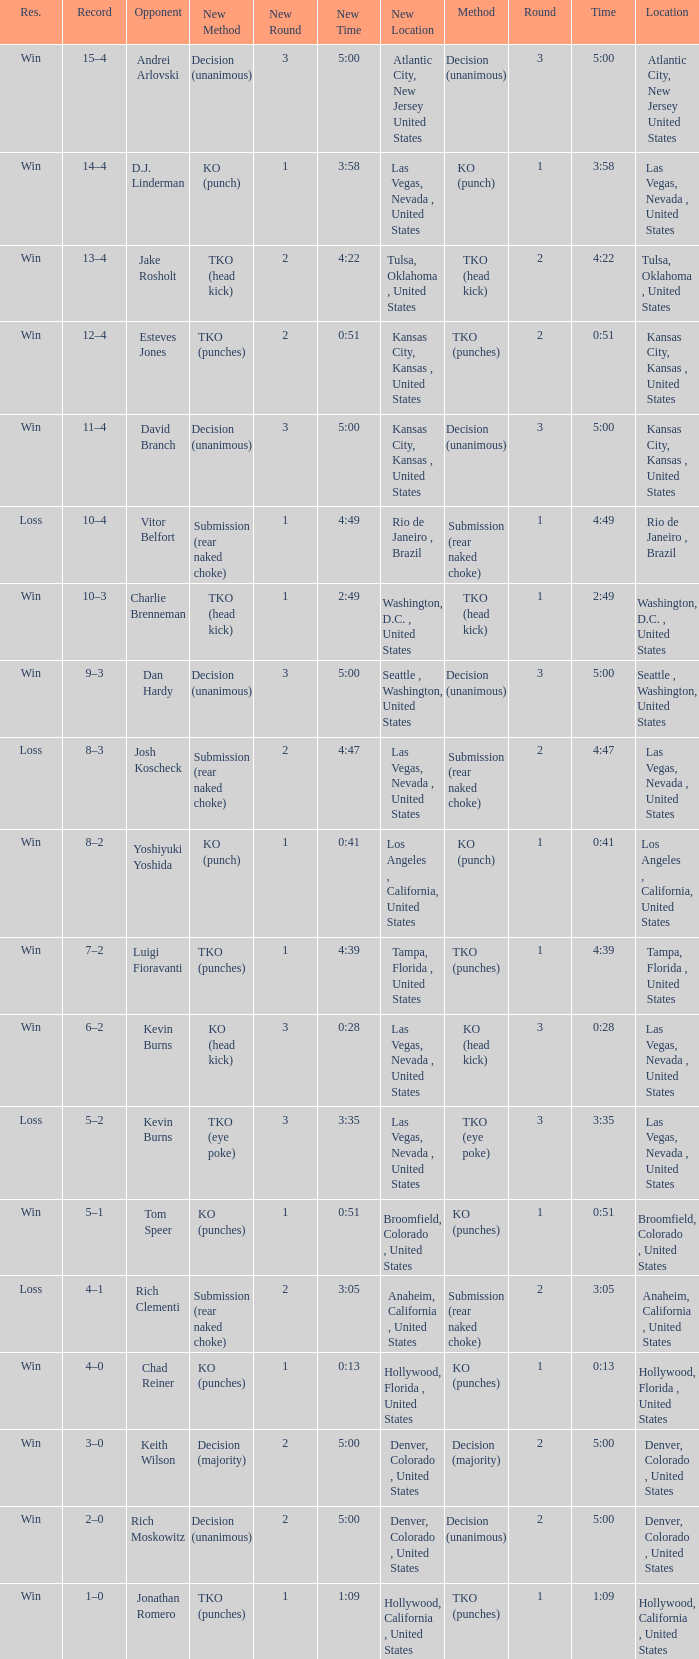Which record has a time of 0:13? 4–0. 